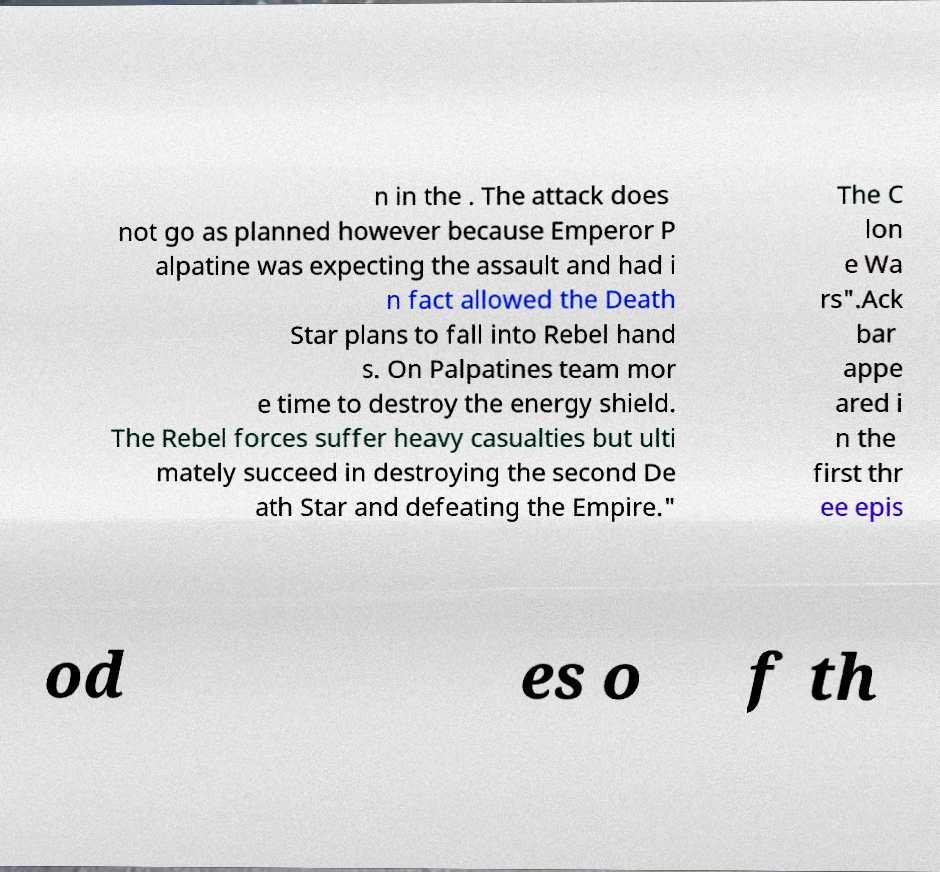Can you accurately transcribe the text from the provided image for me? n in the . The attack does not go as planned however because Emperor P alpatine was expecting the assault and had i n fact allowed the Death Star plans to fall into Rebel hand s. On Palpatines team mor e time to destroy the energy shield. The Rebel forces suffer heavy casualties but ulti mately succeed in destroying the second De ath Star and defeating the Empire." The C lon e Wa rs".Ack bar appe ared i n the first thr ee epis od es o f th 